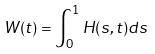<formula> <loc_0><loc_0><loc_500><loc_500>W ( t ) = \int _ { 0 } ^ { 1 } H ( s , t ) d s</formula> 